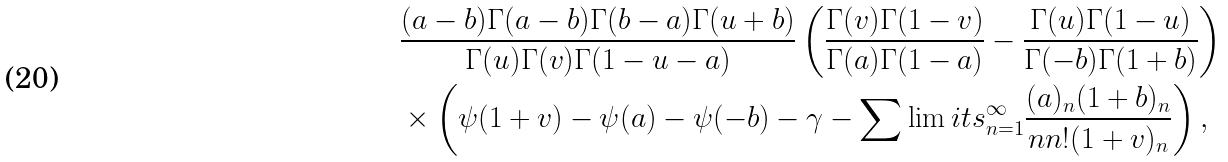<formula> <loc_0><loc_0><loc_500><loc_500>& \frac { ( a - b ) \Gamma ( a - b ) \Gamma ( b - a ) \Gamma ( u + b ) } { \Gamma ( u ) \Gamma ( v ) \Gamma ( 1 - u - a ) } \left ( \frac { \Gamma ( v ) \Gamma ( 1 - v ) } { \Gamma ( a ) \Gamma ( 1 - a ) } - \frac { \Gamma ( u ) \Gamma ( 1 - u ) } { \Gamma ( - b ) \Gamma ( 1 + b ) } \right ) \\ & \times \left ( \psi ( 1 + v ) - \psi ( a ) - \psi ( - b ) - \gamma - \sum \lim i t s _ { n = 1 } ^ { \infty } \frac { ( a ) _ { n } ( 1 + b ) _ { n } } { n n ! ( 1 + v ) _ { n } } \right ) ,</formula> 